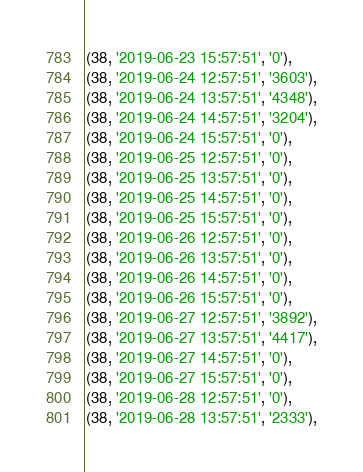Convert code to text. <code><loc_0><loc_0><loc_500><loc_500><_SQL_>(38, '2019-06-23 15:57:51', '0'),
(38, '2019-06-24 12:57:51', '3603'),
(38, '2019-06-24 13:57:51', '4348'),
(38, '2019-06-24 14:57:51', '3204'),
(38, '2019-06-24 15:57:51', '0'),
(38, '2019-06-25 12:57:51', '0'),
(38, '2019-06-25 13:57:51', '0'),
(38, '2019-06-25 14:57:51', '0'),
(38, '2019-06-25 15:57:51', '0'),
(38, '2019-06-26 12:57:51', '0'),
(38, '2019-06-26 13:57:51', '0'),
(38, '2019-06-26 14:57:51', '0'),
(38, '2019-06-26 15:57:51', '0'),
(38, '2019-06-27 12:57:51', '3892'),
(38, '2019-06-27 13:57:51', '4417'),
(38, '2019-06-27 14:57:51', '0'),
(38, '2019-06-27 15:57:51', '0'),
(38, '2019-06-28 12:57:51', '0'),
(38, '2019-06-28 13:57:51', '2333'),</code> 